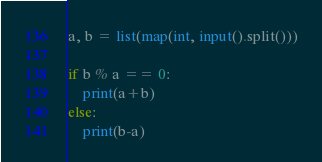<code> <loc_0><loc_0><loc_500><loc_500><_Python_>a, b = list(map(int, input().split()))

if b % a == 0:
    print(a+b)
else:
    print(b-a)
</code> 